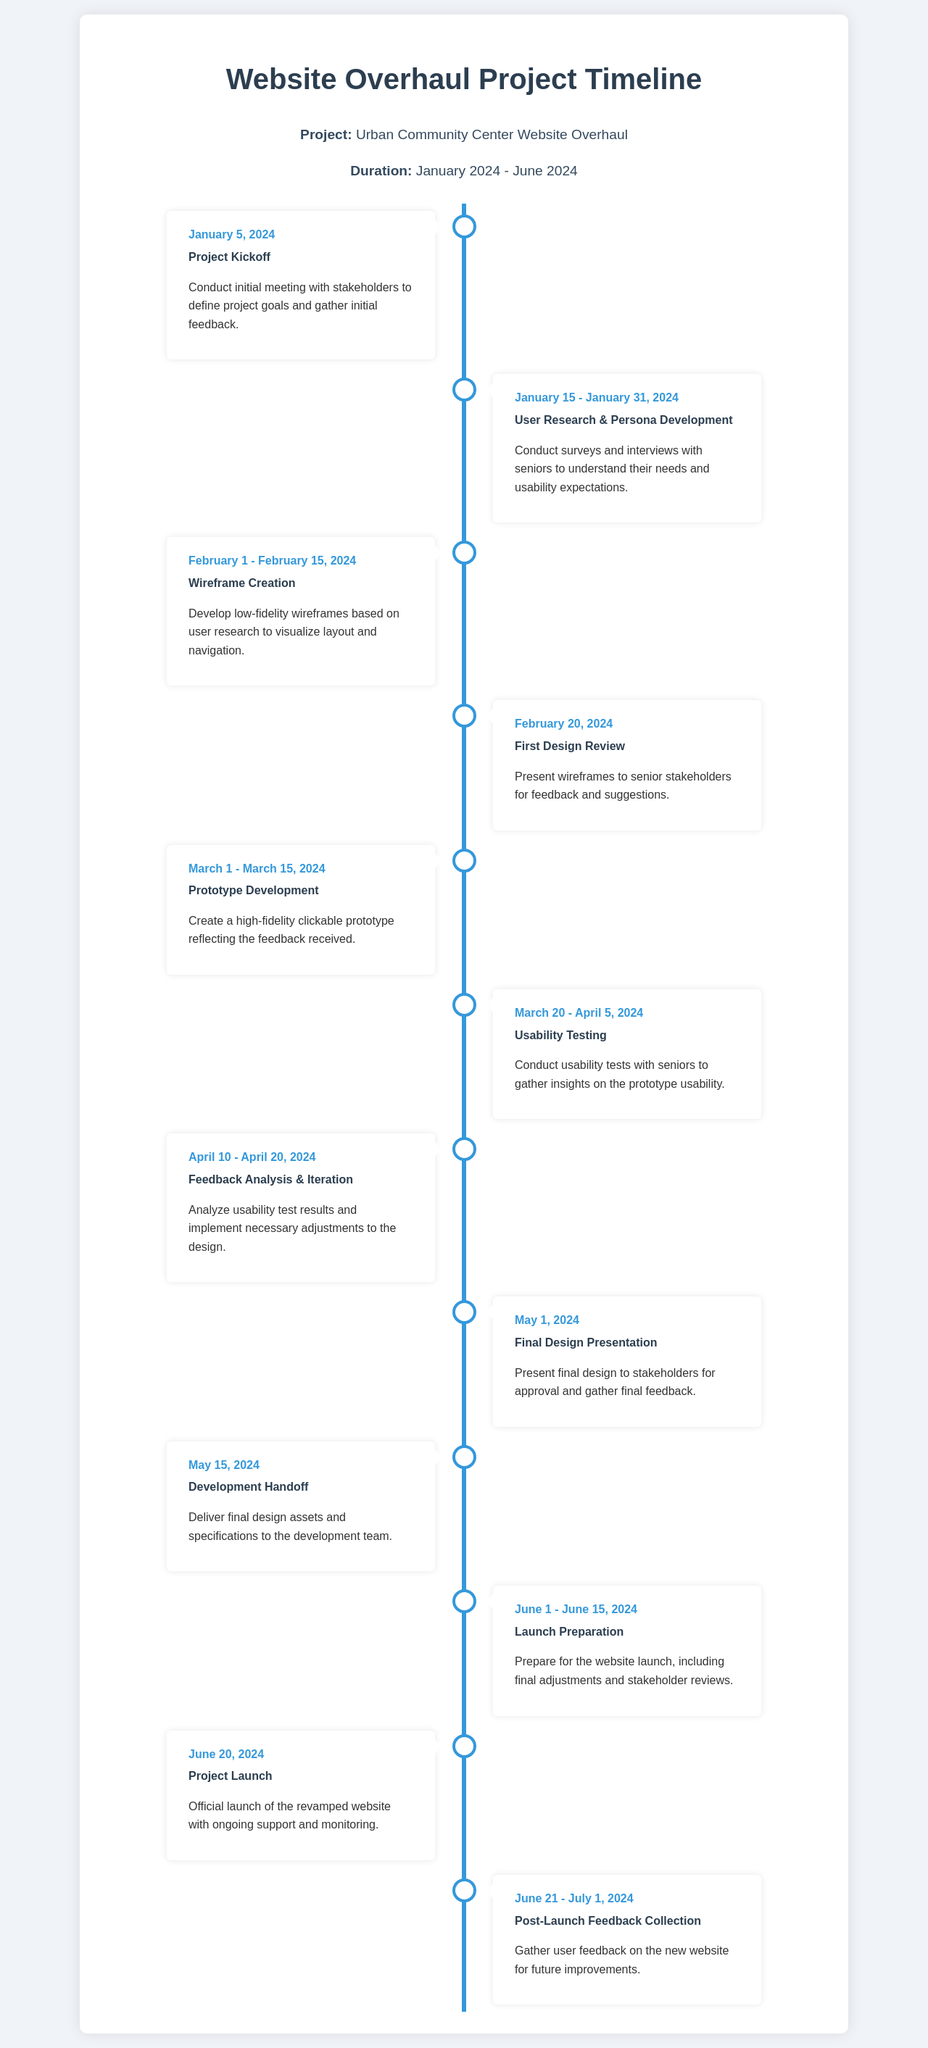what is the duration of the project? The duration of the project is stated in the project info section of the document.
Answer: January 2024 - June 2024 what is the title of the first milestone? The title of the first milestone can be found in the timeline section.
Answer: Project Kickoff when is the final design presentation scheduled? The date of the final design presentation is specifically mentioned in the timeline.
Answer: May 1, 2024 how many phases involve user feedback? This requires counting the milestones that include user feedback based on the document.
Answer: Four what is the main purpose of the usability testing phase? The purpose can be inferred from the description of the usability testing milestone.
Answer: Gather insights on prototype usability on which date is the project launch planned? The launch date is explicitly stated within the timeline of the document.
Answer: June 20, 2024 what is the activity after the final design presentation? This answer involves knowing the sequence of milestones related to the project.
Answer: Development Handoff which milestone involves feedback analysis? This question asks for the name of a specific milestone as described in the document.
Answer: Feedback Analysis & Iteration 